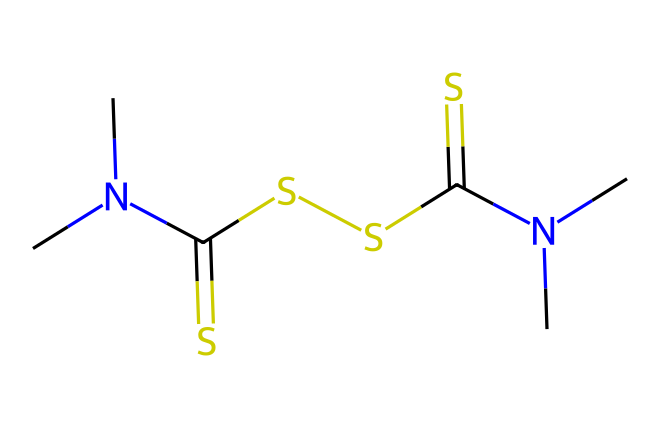How many nitrogen atoms are present in the chemical? By examining the SMILES representation, we note that the letters "N" signify nitrogen atoms. In the provided structure, "N(C)C" appears twice, indicating there are two nitrogen atoms attached to carbon moieties.
Answer: two What is the main functional group found in this chemical? Looking at the structure, the presence of the thioamide functional group can be identified by the "C(=S)" portion which includes a carbon double bonded to sulfur. This indicates the compound has thioamide characteristics, typical in the structure of thiram.
Answer: thioamide How many sulfur atoms exist in this molecule? In the given SMILES, the "S" symbols indicate sulfur atoms. By counting, there are three separate occurrences of "S" in the structure. Thus, we conclude there are three sulfur atoms.
Answer: three What type of compound is thiram classified as? Given that thiram is specifically designed to combat fungal growth, it is classified as a fungicide. The structure includes nitrogen and sulfur, typical in many antifungal agents which target specific pathogen pathways.
Answer: fungicide What is the total number of carbon atoms in this chemical? The "C" in the SMILES denotes carbon atoms. By counting the distinct occurrences of "C" in this structure, we find a total of six carbon atoms present within the entire molecular structure.
Answer: six Are there any methyl groups present? The "N(C)C" segments in the SMILES suggest the presence of methyl groups, as they are denoted by the "C" directly attached to the nitrogen atoms. Each of these contributes a methyl group.
Answer: yes What is the charge state of the molecule? The SMILES does not contain any ion designations and all atoms are neutral in the structure provided; hence, we can deduce that the molecule is uncharged overall given its neutral arrangement of atoms.
Answer: neutral 